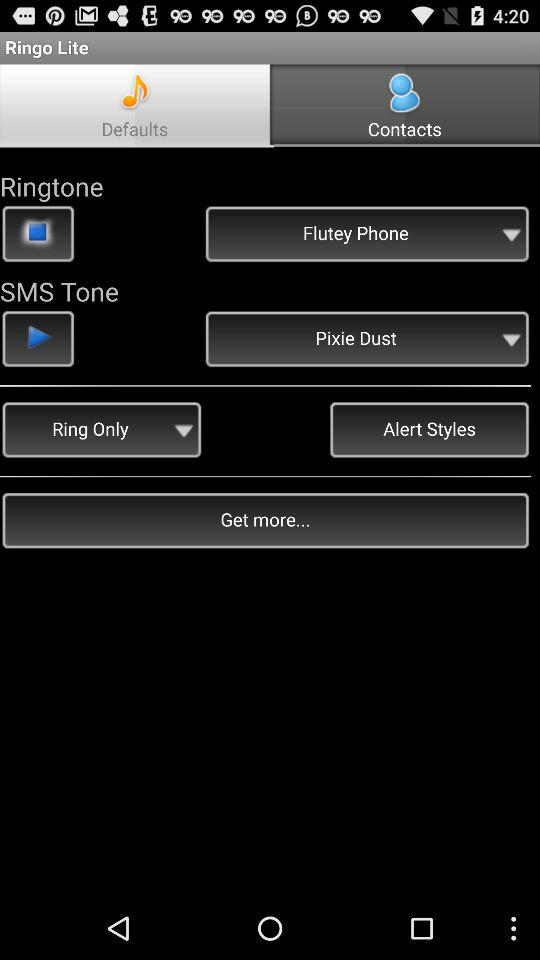Which tab is selected? The selected tab is "Defaults". 